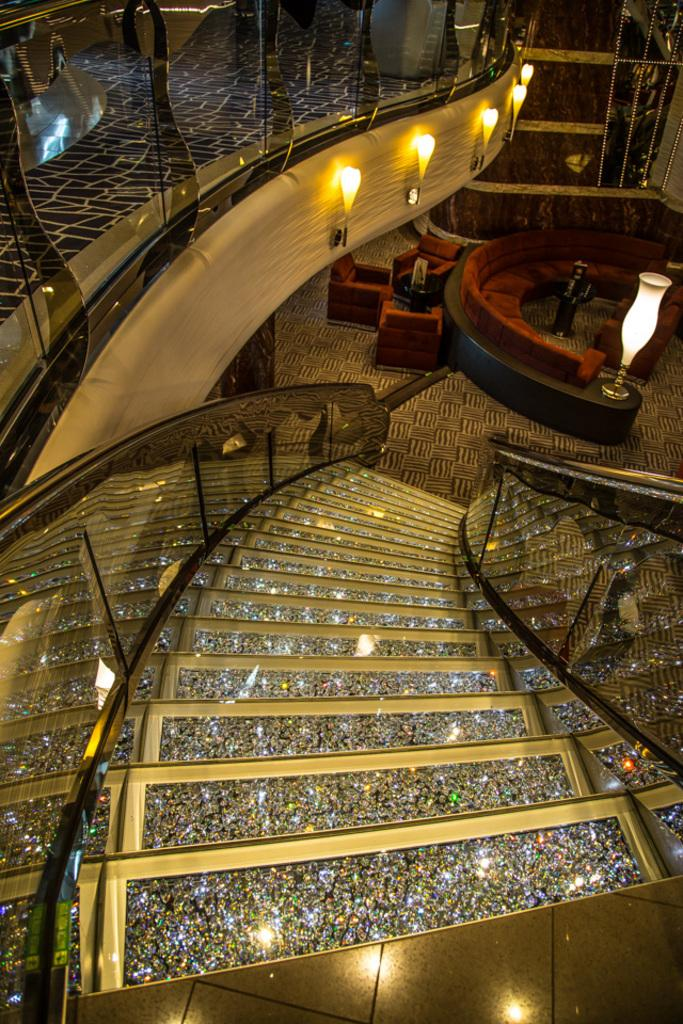What is the main feature in the center of the image? There are stairs in the center of the image. What can be seen in the top left corner of the image? Lights and floor are visible in the top left corner of the image. What type of furniture is in the background of the image? There is a sofa and chairs present in the background of the image. Can you describe the lighting in the background of the image? There is a light visible in the background of the image. What type of architectural feature is in the background of the image? There is a wall in the background of the image. What is the mass of the rat in the image? There is no rat present in the image, so it is not possible to determine its mass. 